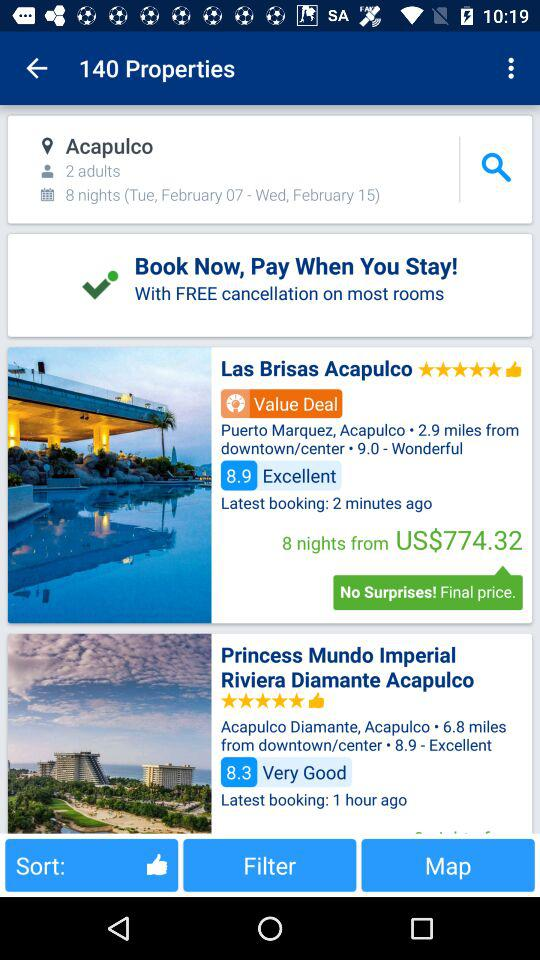How far away is Acapulco Diamante, Acapulco from the downtown or center? Acapulco Diamante, Acapulco is 6.8 miles away from the downtown or center. 